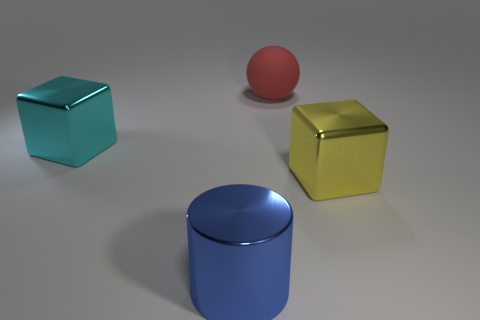Add 1 large metallic cylinders. How many objects exist? 5 Subtract all spheres. How many objects are left? 3 Subtract all purple shiny blocks. Subtract all big red rubber balls. How many objects are left? 3 Add 1 blue things. How many blue things are left? 2 Add 3 blue shiny cylinders. How many blue shiny cylinders exist? 4 Subtract 0 cyan balls. How many objects are left? 4 